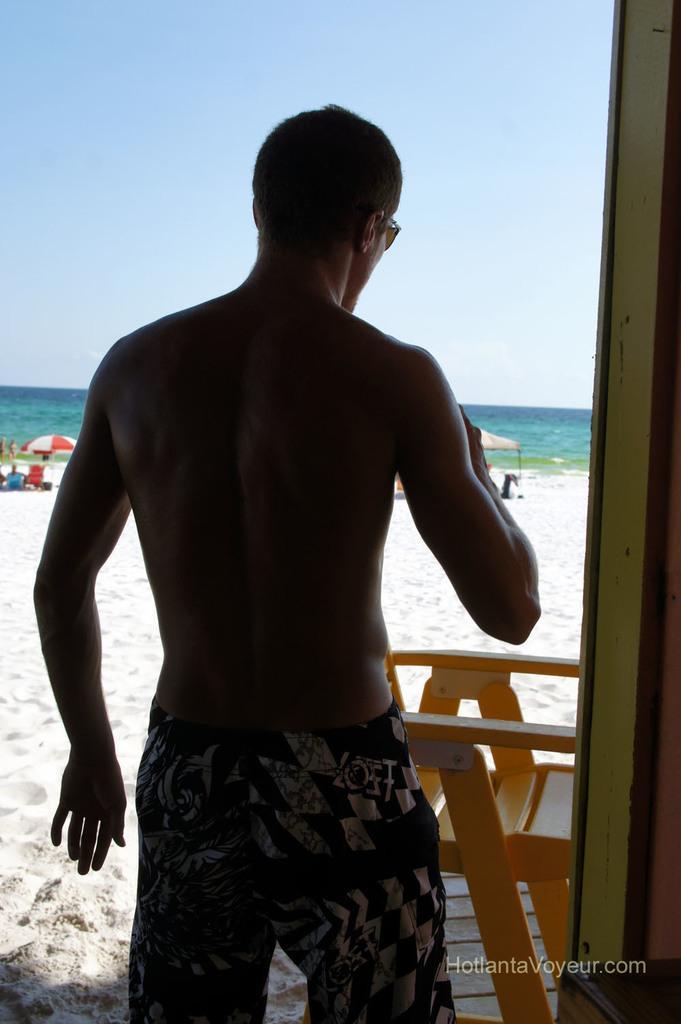In one or two sentences, can you explain what this image depicts? In the foreground of the picture there is a person standing and there is a chair, in front of him there is sand. In the background there are umbrellas, beach chairs and people. In the background it is water. Sky is sunny. 